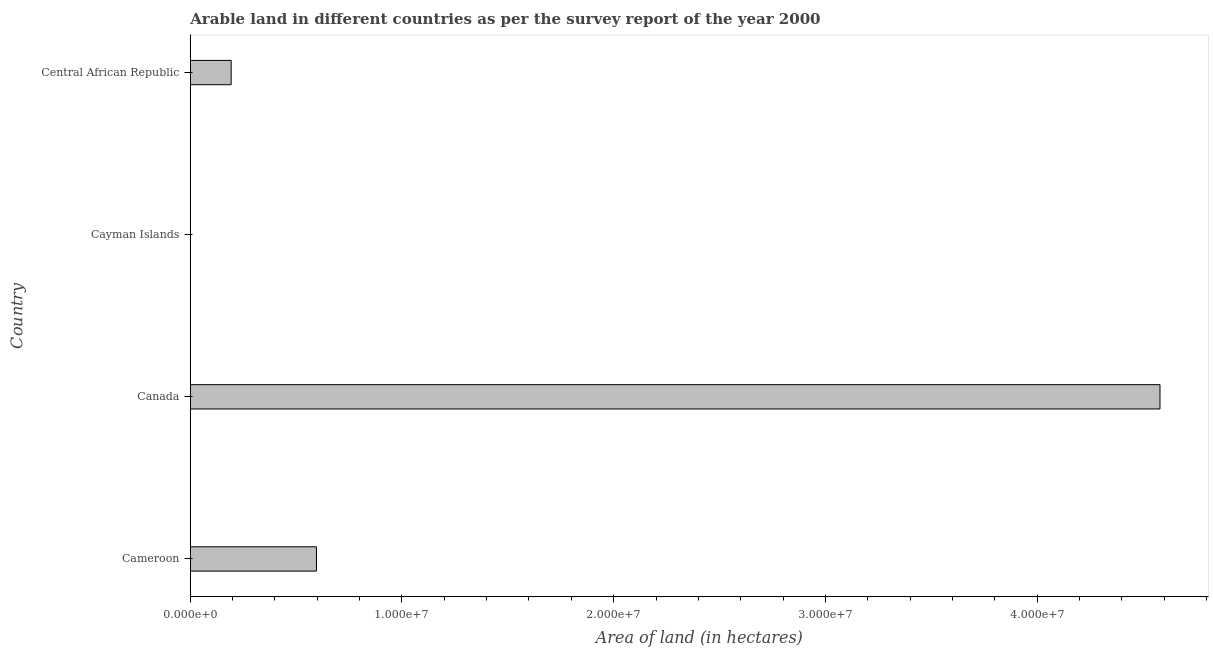Does the graph contain any zero values?
Offer a very short reply. No. What is the title of the graph?
Keep it short and to the point. Arable land in different countries as per the survey report of the year 2000. What is the label or title of the X-axis?
Provide a succinct answer. Area of land (in hectares). What is the area of land in Cameroon?
Ensure brevity in your answer.  5.96e+06. Across all countries, what is the maximum area of land?
Keep it short and to the point. 4.58e+07. In which country was the area of land maximum?
Keep it short and to the point. Canada. In which country was the area of land minimum?
Provide a succinct answer. Cayman Islands. What is the sum of the area of land?
Provide a succinct answer. 5.37e+07. What is the difference between the area of land in Canada and Central African Republic?
Offer a terse response. 4.39e+07. What is the average area of land per country?
Offer a very short reply. 1.34e+07. What is the median area of land?
Your answer should be compact. 3.94e+06. In how many countries, is the area of land greater than 40000000 hectares?
Your answer should be compact. 1. What is the ratio of the area of land in Cameroon to that in Central African Republic?
Give a very brief answer. 3.09. Is the area of land in Cameroon less than that in Cayman Islands?
Your response must be concise. No. What is the difference between the highest and the second highest area of land?
Offer a very short reply. 3.98e+07. What is the difference between the highest and the lowest area of land?
Your response must be concise. 4.58e+07. In how many countries, is the area of land greater than the average area of land taken over all countries?
Your answer should be very brief. 1. How many countries are there in the graph?
Provide a succinct answer. 4. What is the difference between two consecutive major ticks on the X-axis?
Provide a short and direct response. 1.00e+07. Are the values on the major ticks of X-axis written in scientific E-notation?
Make the answer very short. Yes. What is the Area of land (in hectares) of Cameroon?
Your response must be concise. 5.96e+06. What is the Area of land (in hectares) in Canada?
Keep it short and to the point. 4.58e+07. What is the Area of land (in hectares) of Cayman Islands?
Offer a very short reply. 200. What is the Area of land (in hectares) of Central African Republic?
Keep it short and to the point. 1.93e+06. What is the difference between the Area of land (in hectares) in Cameroon and Canada?
Your answer should be compact. -3.98e+07. What is the difference between the Area of land (in hectares) in Cameroon and Cayman Islands?
Offer a very short reply. 5.96e+06. What is the difference between the Area of land (in hectares) in Cameroon and Central African Republic?
Keep it short and to the point. 4.03e+06. What is the difference between the Area of land (in hectares) in Canada and Cayman Islands?
Give a very brief answer. 4.58e+07. What is the difference between the Area of land (in hectares) in Canada and Central African Republic?
Keep it short and to the point. 4.39e+07. What is the difference between the Area of land (in hectares) in Cayman Islands and Central African Republic?
Offer a very short reply. -1.93e+06. What is the ratio of the Area of land (in hectares) in Cameroon to that in Canada?
Provide a succinct answer. 0.13. What is the ratio of the Area of land (in hectares) in Cameroon to that in Cayman Islands?
Your response must be concise. 2.98e+04. What is the ratio of the Area of land (in hectares) in Cameroon to that in Central African Republic?
Provide a succinct answer. 3.09. What is the ratio of the Area of land (in hectares) in Canada to that in Cayman Islands?
Provide a short and direct response. 2.29e+05. What is the ratio of the Area of land (in hectares) in Canada to that in Central African Republic?
Ensure brevity in your answer.  23.74. 